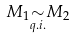Convert formula to latex. <formula><loc_0><loc_0><loc_500><loc_500>M _ { 1 } { \underset { q . i . } { \sim } } M _ { 2 }</formula> 